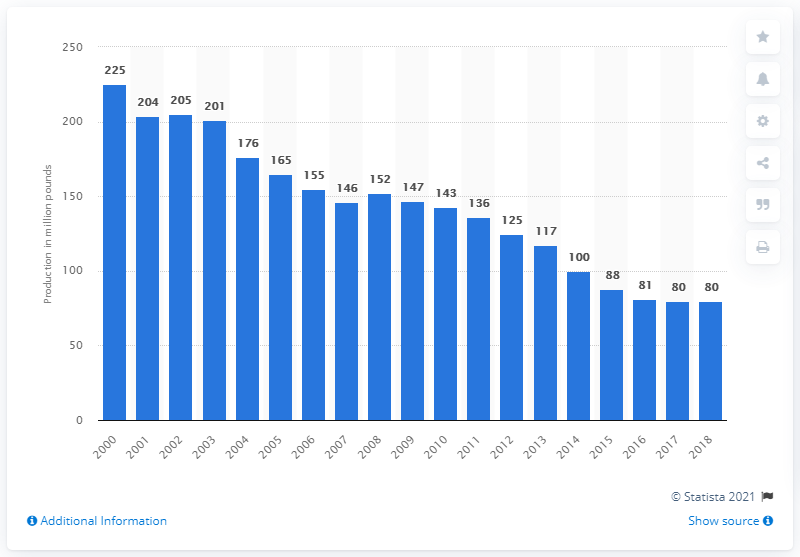Give some essential details in this illustration. In 2018, the production of veal in the United States was approximately 80 million pounds. 